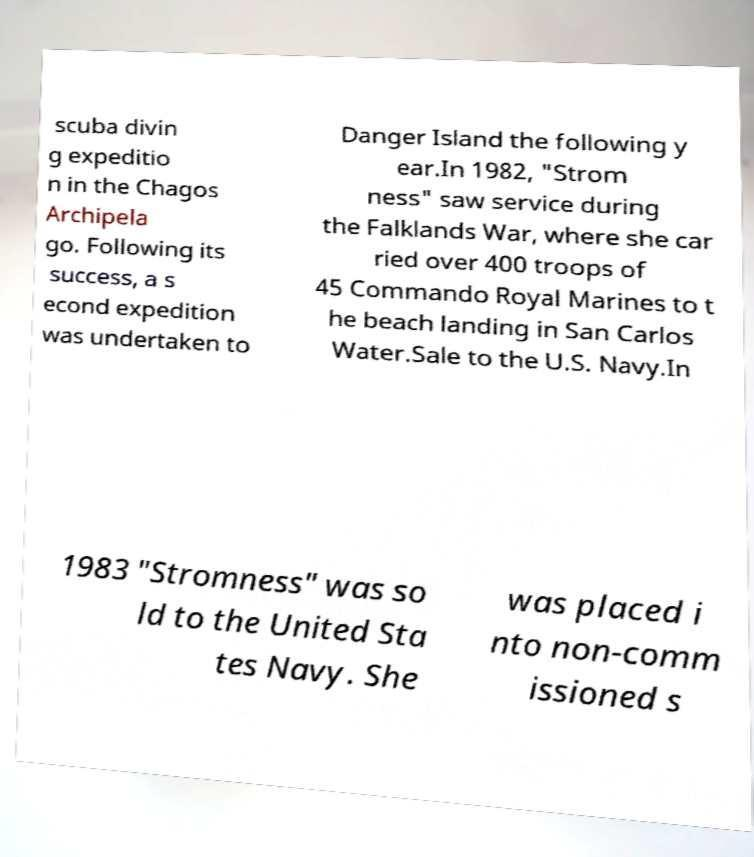Could you assist in decoding the text presented in this image and type it out clearly? scuba divin g expeditio n in the Chagos Archipela go. Following its success, a s econd expedition was undertaken to Danger Island the following y ear.In 1982, "Strom ness" saw service during the Falklands War, where she car ried over 400 troops of 45 Commando Royal Marines to t he beach landing in San Carlos Water.Sale to the U.S. Navy.In 1983 "Stromness" was so ld to the United Sta tes Navy. She was placed i nto non-comm issioned s 